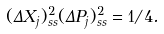<formula> <loc_0><loc_0><loc_500><loc_500>( \Delta X _ { j } ) ^ { 2 } _ { s s } ( \Delta P _ { j } ) ^ { 2 } _ { s s } = 1 / 4 .</formula> 